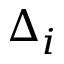<formula> <loc_0><loc_0><loc_500><loc_500>\Delta _ { i }</formula> 